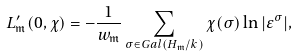<formula> <loc_0><loc_0><loc_500><loc_500>L ^ { \prime } _ { \mathfrak { m } } ( 0 , \chi ) = - \frac { 1 } { w _ { \mathfrak { m } } } \sum _ { \sigma \in G a l ( H _ { \mathfrak { m } } / k ) } \chi ( \sigma ) \ln | \varepsilon ^ { \sigma } | ,</formula> 